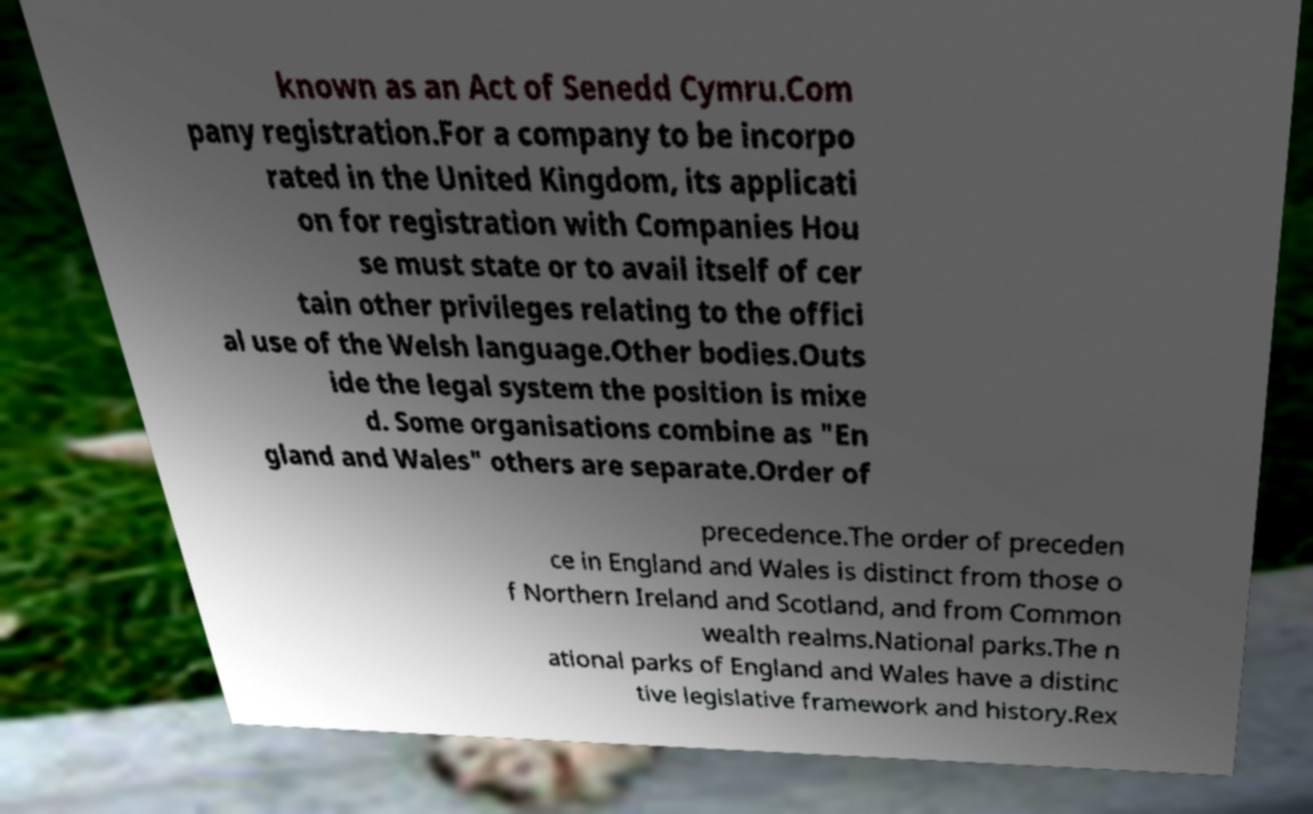There's text embedded in this image that I need extracted. Can you transcribe it verbatim? known as an Act of Senedd Cymru.Com pany registration.For a company to be incorpo rated in the United Kingdom, its applicati on for registration with Companies Hou se must state or to avail itself of cer tain other privileges relating to the offici al use of the Welsh language.Other bodies.Outs ide the legal system the position is mixe d. Some organisations combine as "En gland and Wales" others are separate.Order of precedence.The order of preceden ce in England and Wales is distinct from those o f Northern Ireland and Scotland, and from Common wealth realms.National parks.The n ational parks of England and Wales have a distinc tive legislative framework and history.Rex 